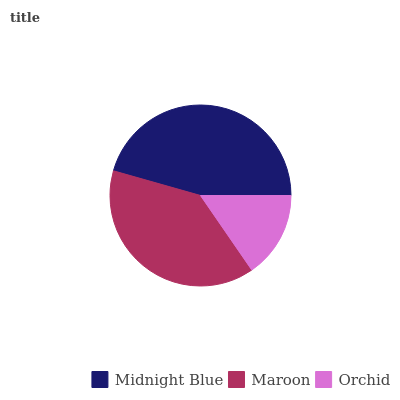Is Orchid the minimum?
Answer yes or no. Yes. Is Midnight Blue the maximum?
Answer yes or no. Yes. Is Maroon the minimum?
Answer yes or no. No. Is Maroon the maximum?
Answer yes or no. No. Is Midnight Blue greater than Maroon?
Answer yes or no. Yes. Is Maroon less than Midnight Blue?
Answer yes or no. Yes. Is Maroon greater than Midnight Blue?
Answer yes or no. No. Is Midnight Blue less than Maroon?
Answer yes or no. No. Is Maroon the high median?
Answer yes or no. Yes. Is Maroon the low median?
Answer yes or no. Yes. Is Midnight Blue the high median?
Answer yes or no. No. Is Midnight Blue the low median?
Answer yes or no. No. 